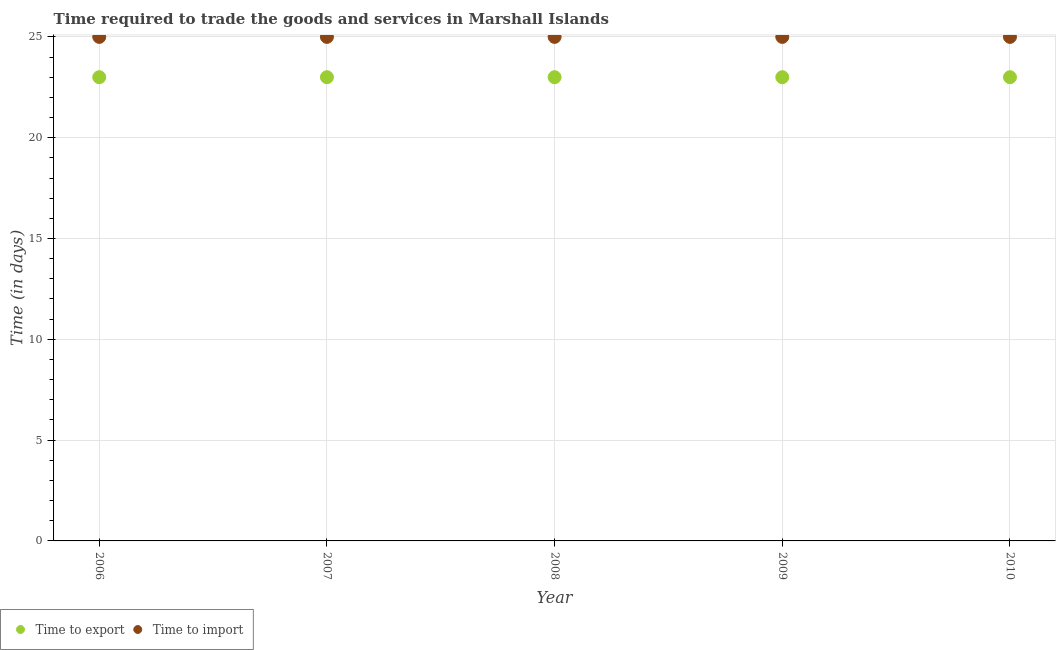How many different coloured dotlines are there?
Keep it short and to the point. 2. What is the time to export in 2010?
Offer a very short reply. 23. Across all years, what is the maximum time to import?
Offer a terse response. 25. Across all years, what is the minimum time to export?
Your answer should be very brief. 23. What is the total time to export in the graph?
Your response must be concise. 115. What is the difference between the time to export in 2010 and the time to import in 2006?
Offer a very short reply. -2. What is the average time to import per year?
Offer a very short reply. 25. In the year 2007, what is the difference between the time to export and time to import?
Give a very brief answer. -2. Is the time to import in 2006 less than that in 2010?
Keep it short and to the point. No. Is the difference between the time to export in 2007 and 2010 greater than the difference between the time to import in 2007 and 2010?
Offer a terse response. No. What is the difference between the highest and the second highest time to import?
Offer a terse response. 0. What is the difference between the highest and the lowest time to import?
Ensure brevity in your answer.  0. How many dotlines are there?
Ensure brevity in your answer.  2. How are the legend labels stacked?
Ensure brevity in your answer.  Horizontal. What is the title of the graph?
Keep it short and to the point. Time required to trade the goods and services in Marshall Islands. Does "IMF nonconcessional" appear as one of the legend labels in the graph?
Ensure brevity in your answer.  No. What is the label or title of the X-axis?
Your answer should be very brief. Year. What is the label or title of the Y-axis?
Offer a very short reply. Time (in days). What is the Time (in days) of Time to export in 2006?
Your response must be concise. 23. What is the Time (in days) in Time to import in 2006?
Offer a very short reply. 25. What is the Time (in days) of Time to export in 2007?
Your response must be concise. 23. What is the Time (in days) of Time to export in 2008?
Keep it short and to the point. 23. What is the Time (in days) of Time to import in 2009?
Your response must be concise. 25. Across all years, what is the maximum Time (in days) in Time to import?
Ensure brevity in your answer.  25. Across all years, what is the minimum Time (in days) in Time to import?
Make the answer very short. 25. What is the total Time (in days) in Time to export in the graph?
Ensure brevity in your answer.  115. What is the total Time (in days) of Time to import in the graph?
Offer a very short reply. 125. What is the difference between the Time (in days) of Time to export in 2006 and that in 2008?
Give a very brief answer. 0. What is the difference between the Time (in days) of Time to import in 2006 and that in 2008?
Provide a succinct answer. 0. What is the difference between the Time (in days) in Time to export in 2006 and that in 2009?
Provide a succinct answer. 0. What is the difference between the Time (in days) of Time to export in 2006 and that in 2010?
Your response must be concise. 0. What is the difference between the Time (in days) in Time to import in 2007 and that in 2008?
Keep it short and to the point. 0. What is the difference between the Time (in days) of Time to export in 2007 and that in 2009?
Provide a short and direct response. 0. What is the difference between the Time (in days) of Time to import in 2007 and that in 2009?
Your answer should be compact. 0. What is the difference between the Time (in days) in Time to import in 2007 and that in 2010?
Ensure brevity in your answer.  0. What is the difference between the Time (in days) of Time to import in 2008 and that in 2009?
Ensure brevity in your answer.  0. What is the difference between the Time (in days) of Time to export in 2008 and that in 2010?
Your answer should be compact. 0. What is the difference between the Time (in days) in Time to import in 2008 and that in 2010?
Your response must be concise. 0. What is the difference between the Time (in days) in Time to export in 2009 and that in 2010?
Provide a succinct answer. 0. What is the difference between the Time (in days) in Time to export in 2006 and the Time (in days) in Time to import in 2007?
Give a very brief answer. -2. What is the difference between the Time (in days) of Time to export in 2006 and the Time (in days) of Time to import in 2008?
Provide a succinct answer. -2. What is the difference between the Time (in days) of Time to export in 2006 and the Time (in days) of Time to import in 2009?
Your answer should be very brief. -2. What is the difference between the Time (in days) in Time to export in 2006 and the Time (in days) in Time to import in 2010?
Offer a terse response. -2. What is the difference between the Time (in days) in Time to export in 2007 and the Time (in days) in Time to import in 2010?
Ensure brevity in your answer.  -2. What is the difference between the Time (in days) of Time to export in 2008 and the Time (in days) of Time to import in 2009?
Offer a very short reply. -2. In the year 2007, what is the difference between the Time (in days) in Time to export and Time (in days) in Time to import?
Keep it short and to the point. -2. In the year 2008, what is the difference between the Time (in days) in Time to export and Time (in days) in Time to import?
Your answer should be very brief. -2. In the year 2010, what is the difference between the Time (in days) in Time to export and Time (in days) in Time to import?
Make the answer very short. -2. What is the ratio of the Time (in days) of Time to export in 2006 to that in 2007?
Offer a very short reply. 1. What is the ratio of the Time (in days) in Time to import in 2006 to that in 2007?
Give a very brief answer. 1. What is the ratio of the Time (in days) in Time to export in 2006 to that in 2009?
Provide a short and direct response. 1. What is the ratio of the Time (in days) of Time to import in 2006 to that in 2009?
Keep it short and to the point. 1. What is the ratio of the Time (in days) in Time to export in 2007 to that in 2009?
Offer a very short reply. 1. What is the ratio of the Time (in days) of Time to export in 2007 to that in 2010?
Your response must be concise. 1. What is the ratio of the Time (in days) of Time to export in 2008 to that in 2009?
Ensure brevity in your answer.  1. What is the ratio of the Time (in days) in Time to export in 2008 to that in 2010?
Keep it short and to the point. 1. What is the ratio of the Time (in days) in Time to import in 2008 to that in 2010?
Make the answer very short. 1. What is the difference between the highest and the second highest Time (in days) in Time to export?
Offer a terse response. 0. What is the difference between the highest and the lowest Time (in days) of Time to export?
Offer a terse response. 0. What is the difference between the highest and the lowest Time (in days) of Time to import?
Your answer should be compact. 0. 